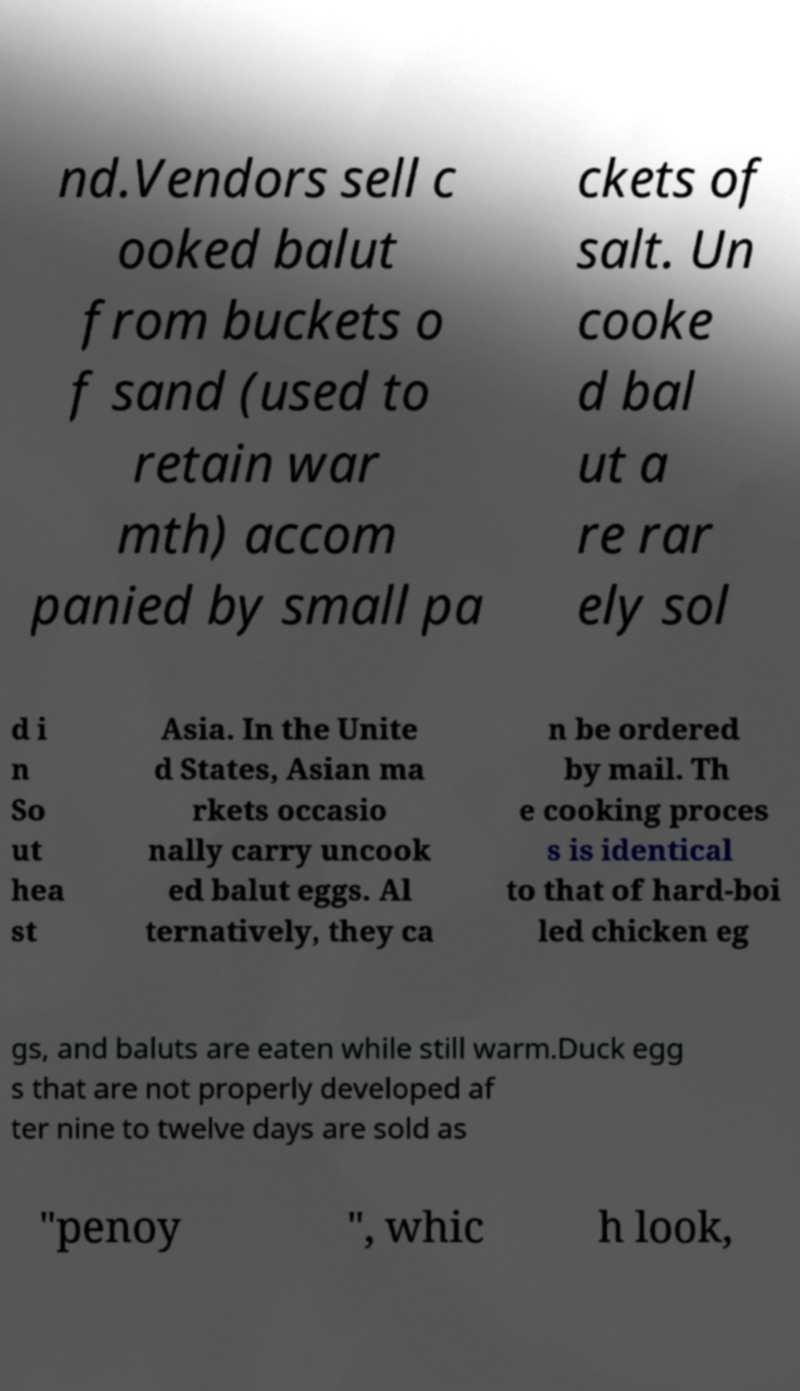Please identify and transcribe the text found in this image. nd.Vendors sell c ooked balut from buckets o f sand (used to retain war mth) accom panied by small pa ckets of salt. Un cooke d bal ut a re rar ely sol d i n So ut hea st Asia. In the Unite d States, Asian ma rkets occasio nally carry uncook ed balut eggs. Al ternatively, they ca n be ordered by mail. Th e cooking proces s is identical to that of hard-boi led chicken eg gs, and baluts are eaten while still warm.Duck egg s that are not properly developed af ter nine to twelve days are sold as "penoy ", whic h look, 